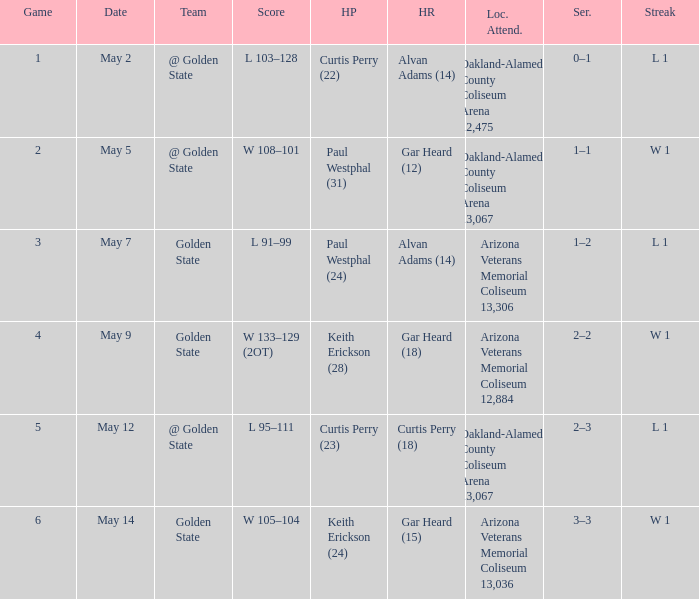How many games had they won or lost in a row on May 9? W 1. 